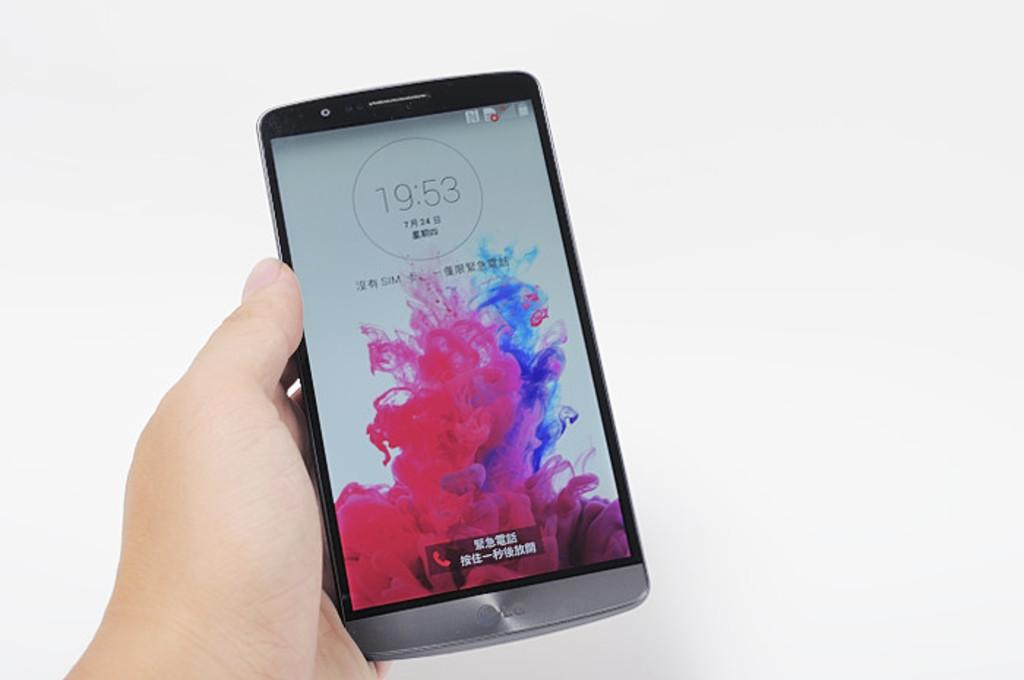Provide a one-sentence caption for the provided image. a hand holding a phone that reads 19:53. 